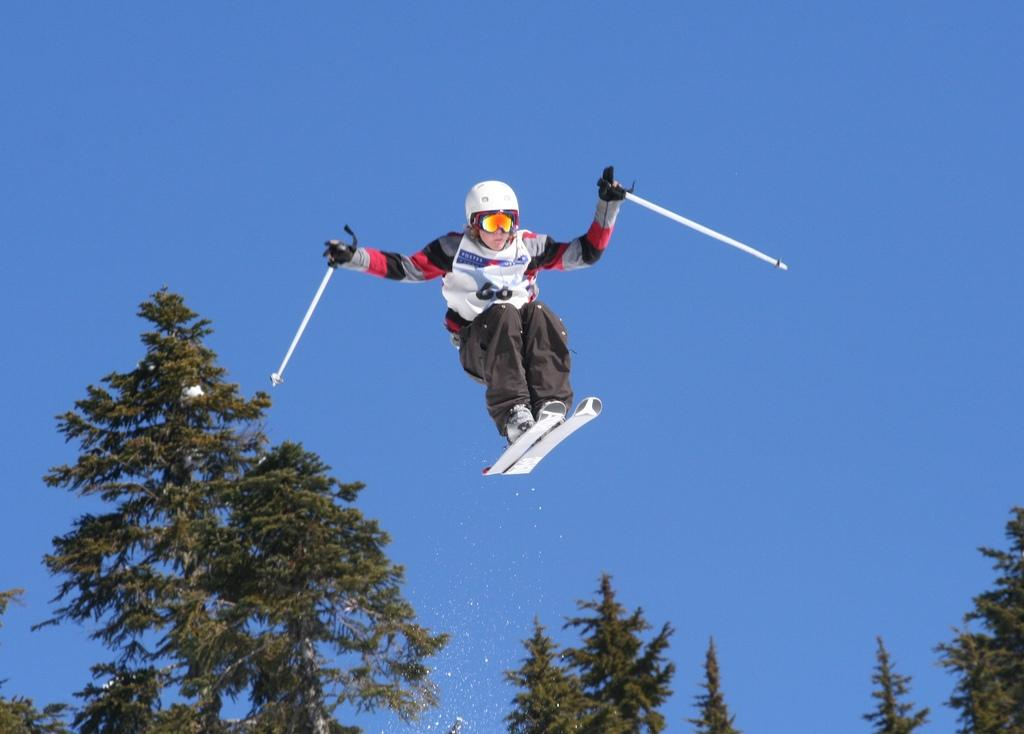What can be seen in the image? There is a person in the image. What is the person wearing? The person is wearing a helmet. What is the person holding? The person is holding skis and sticks. What is the background of the image? There is a group of trees in the image, and the sky is visible. How does the sky look in the image? The sky appears to be cloudy. What theory can be observed in the image? There is no theory present in the image; it features a person wearing a helmet, holding skis and sticks, with a group of trees and a cloudy sky in the background. 